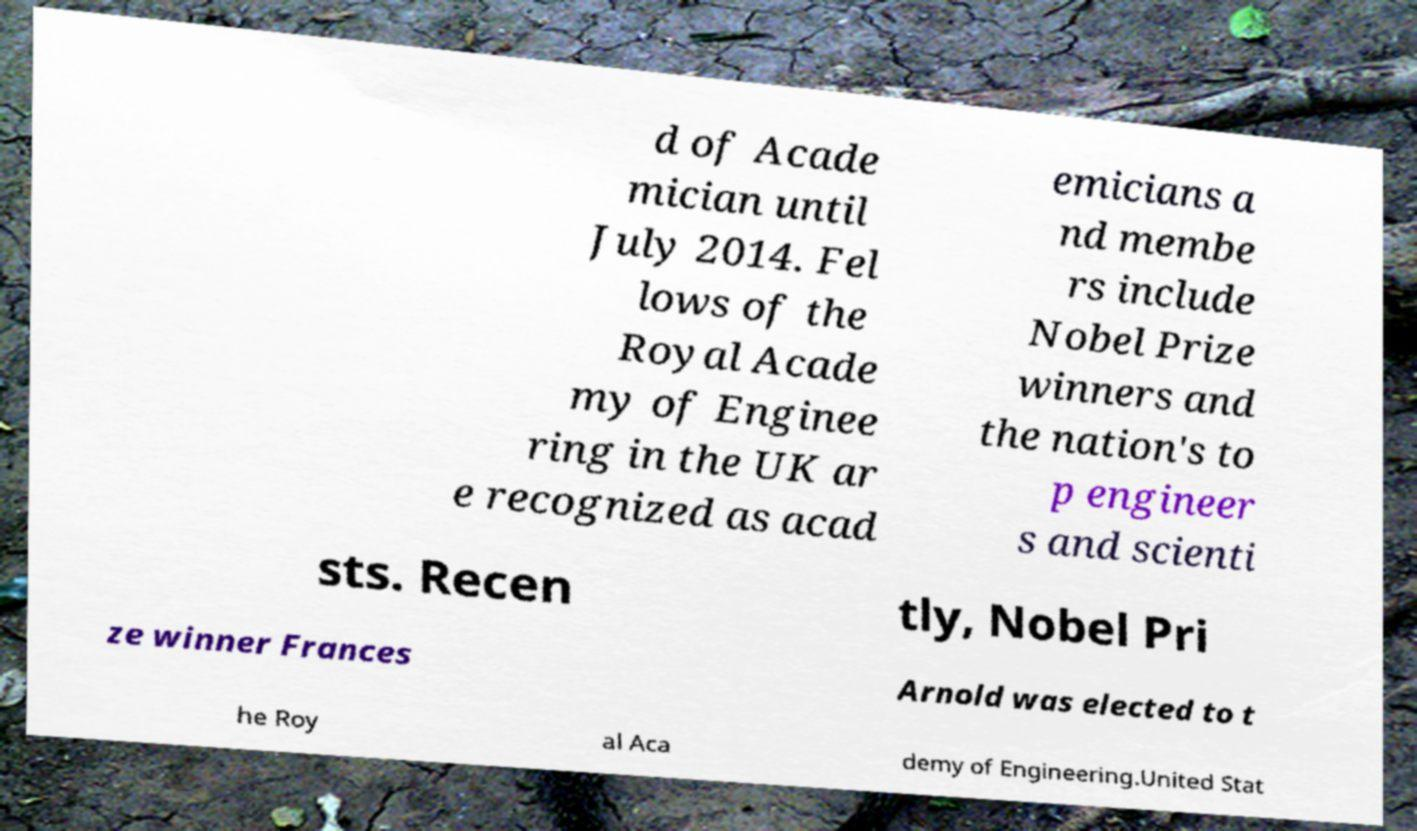Please identify and transcribe the text found in this image. d of Acade mician until July 2014. Fel lows of the Royal Acade my of Enginee ring in the UK ar e recognized as acad emicians a nd membe rs include Nobel Prize winners and the nation's to p engineer s and scienti sts. Recen tly, Nobel Pri ze winner Frances Arnold was elected to t he Roy al Aca demy of Engineering.United Stat 